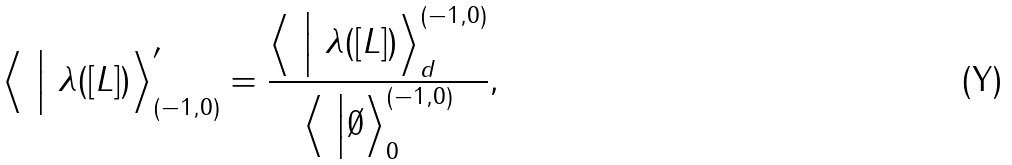<formula> <loc_0><loc_0><loc_500><loc_500>\Big \langle \ \Big | \ \lambda ( [ L ] ) \Big \rangle ^ { \prime } _ { ( - 1 , 0 ) } = \frac { \Big \langle \ \Big | \ \lambda ( [ L ] ) \Big \rangle _ { d } ^ { ( - 1 , 0 ) } } { \Big \langle \ \Big | \emptyset \Big \rangle ^ { ( - 1 , 0 ) } _ { 0 } } ,</formula> 